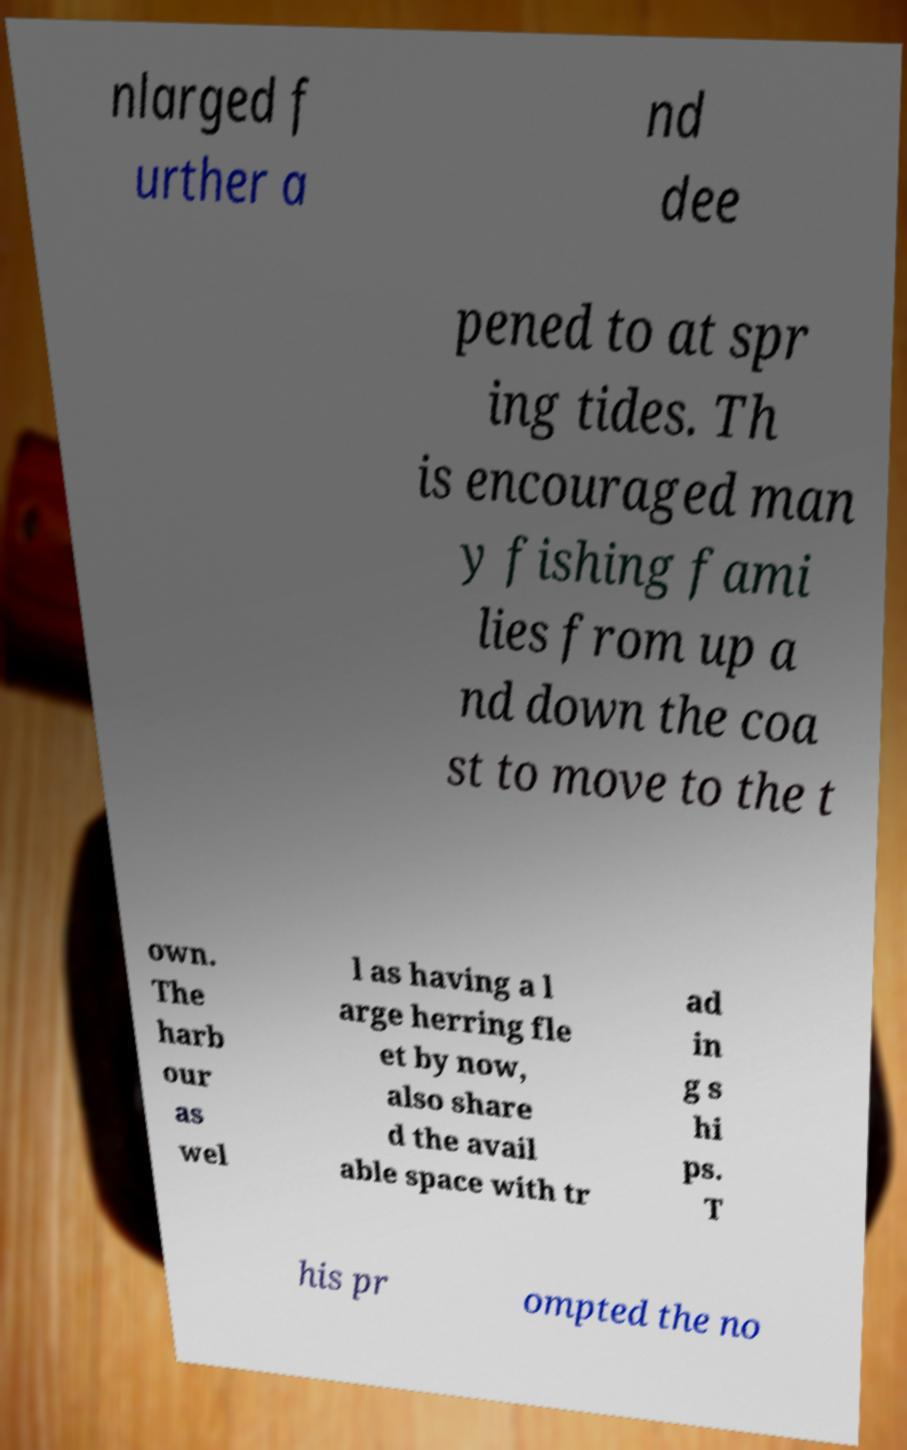Can you accurately transcribe the text from the provided image for me? nlarged f urther a nd dee pened to at spr ing tides. Th is encouraged man y fishing fami lies from up a nd down the coa st to move to the t own. The harb our as wel l as having a l arge herring fle et by now, also share d the avail able space with tr ad in g s hi ps. T his pr ompted the no 